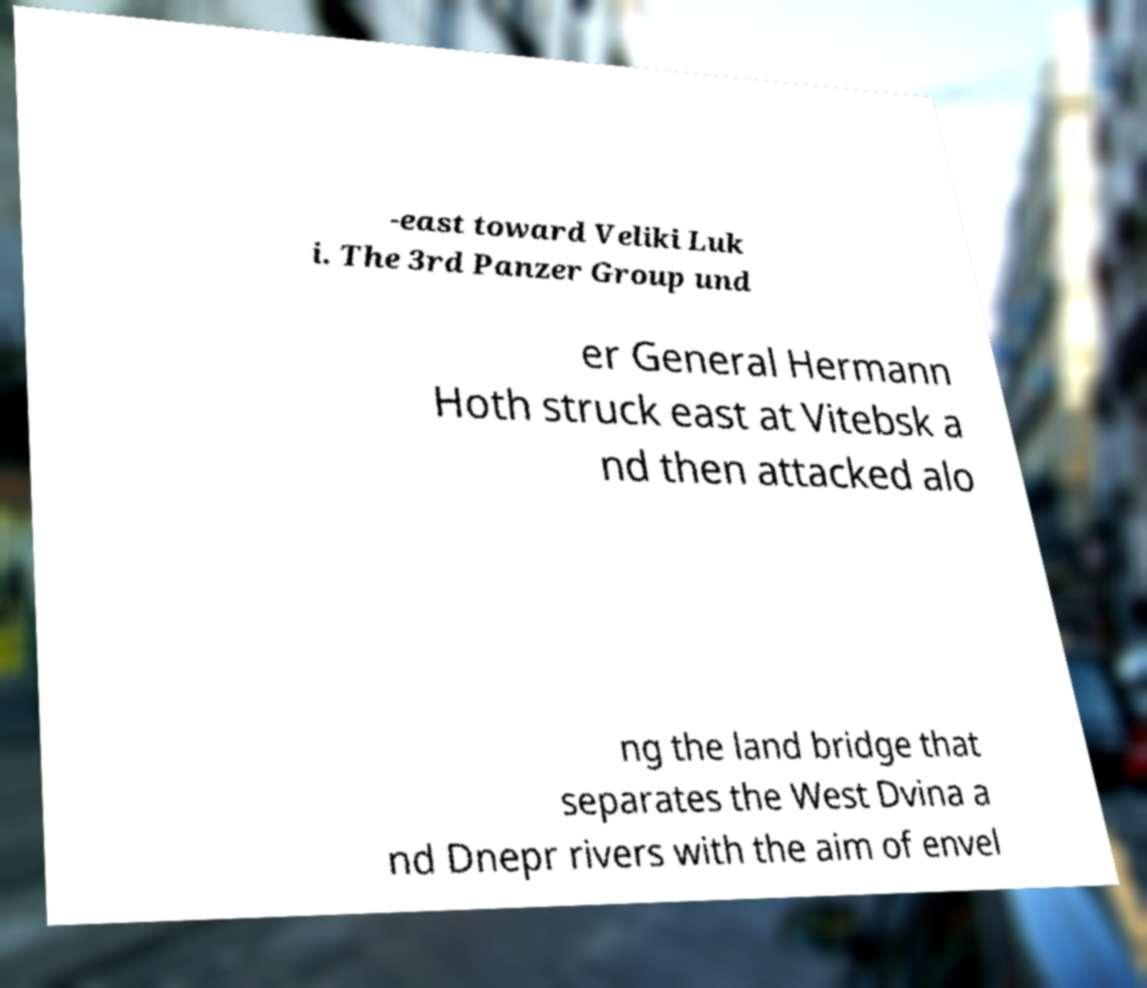Could you assist in decoding the text presented in this image and type it out clearly? -east toward Veliki Luk i. The 3rd Panzer Group und er General Hermann Hoth struck east at Vitebsk a nd then attacked alo ng the land bridge that separates the West Dvina a nd Dnepr rivers with the aim of envel 